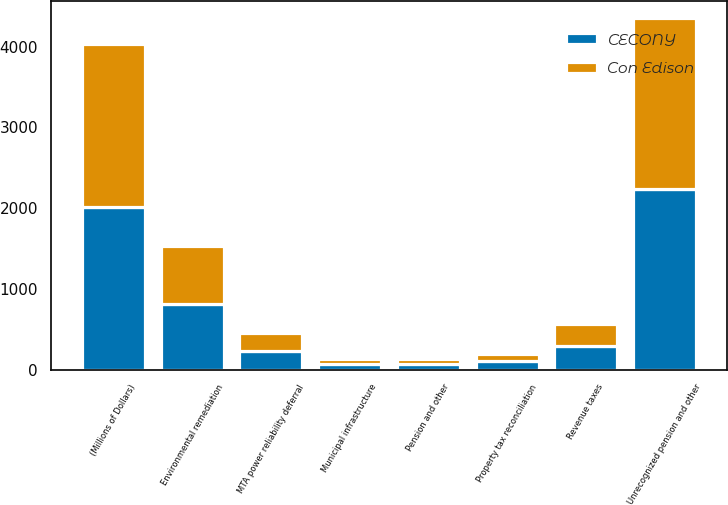<chart> <loc_0><loc_0><loc_500><loc_500><stacked_bar_chart><ecel><fcel>(Millions of Dollars)<fcel>Unrecognized pension and other<fcel>Environmental remediation<fcel>Revenue taxes<fcel>MTA power reliability deferral<fcel>Property tax reconciliation<fcel>Pension and other<fcel>Municipal infrastructure<nl><fcel>CECONY<fcel>2018<fcel>2238<fcel>810<fcel>291<fcel>229<fcel>101<fcel>73<fcel>67<nl><fcel>Con Edison<fcel>2018<fcel>2111<fcel>716<fcel>278<fcel>229<fcel>86<fcel>56<fcel>67<nl></chart> 